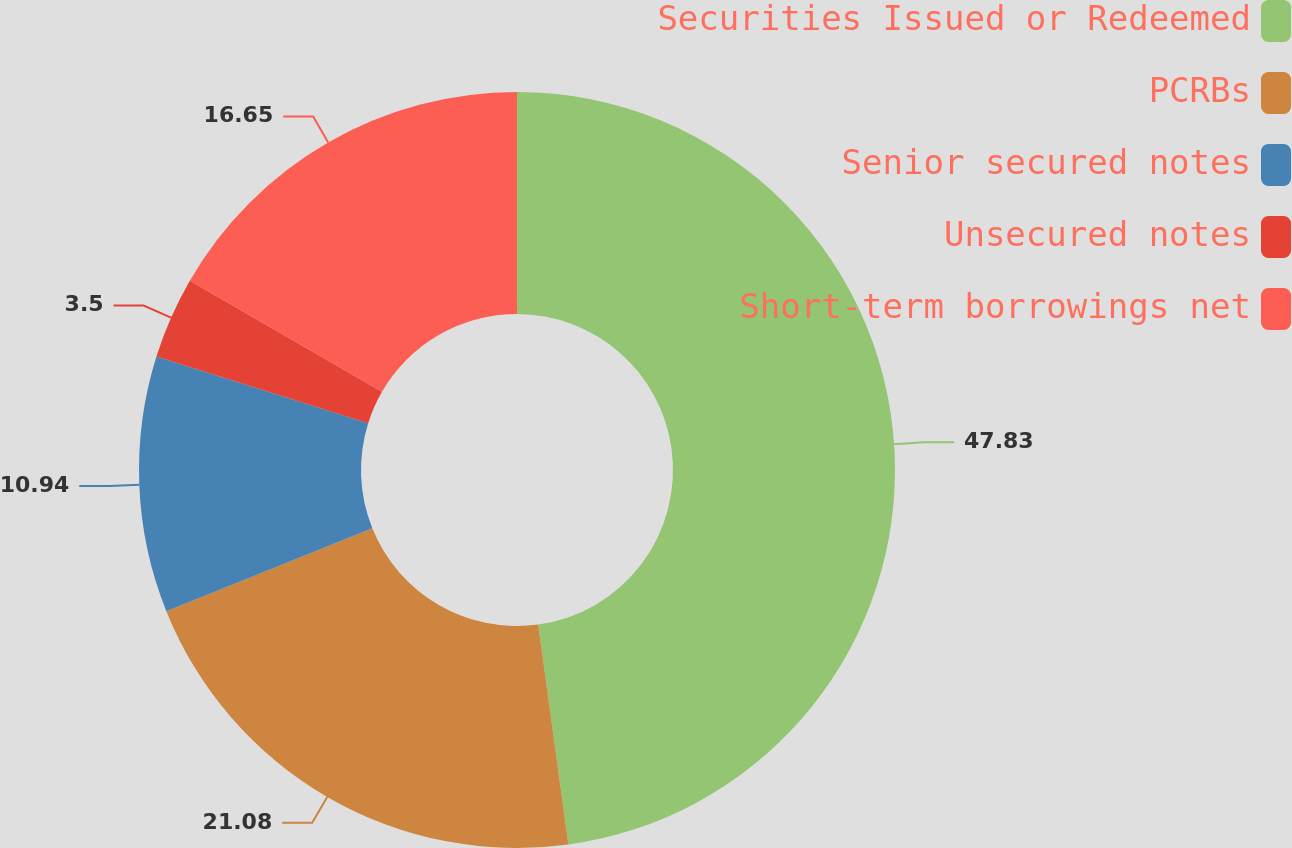Convert chart. <chart><loc_0><loc_0><loc_500><loc_500><pie_chart><fcel>Securities Issued or Redeemed<fcel>PCRBs<fcel>Senior secured notes<fcel>Unsecured notes<fcel>Short-term borrowings net<nl><fcel>47.83%<fcel>21.08%<fcel>10.94%<fcel>3.5%<fcel>16.65%<nl></chart> 